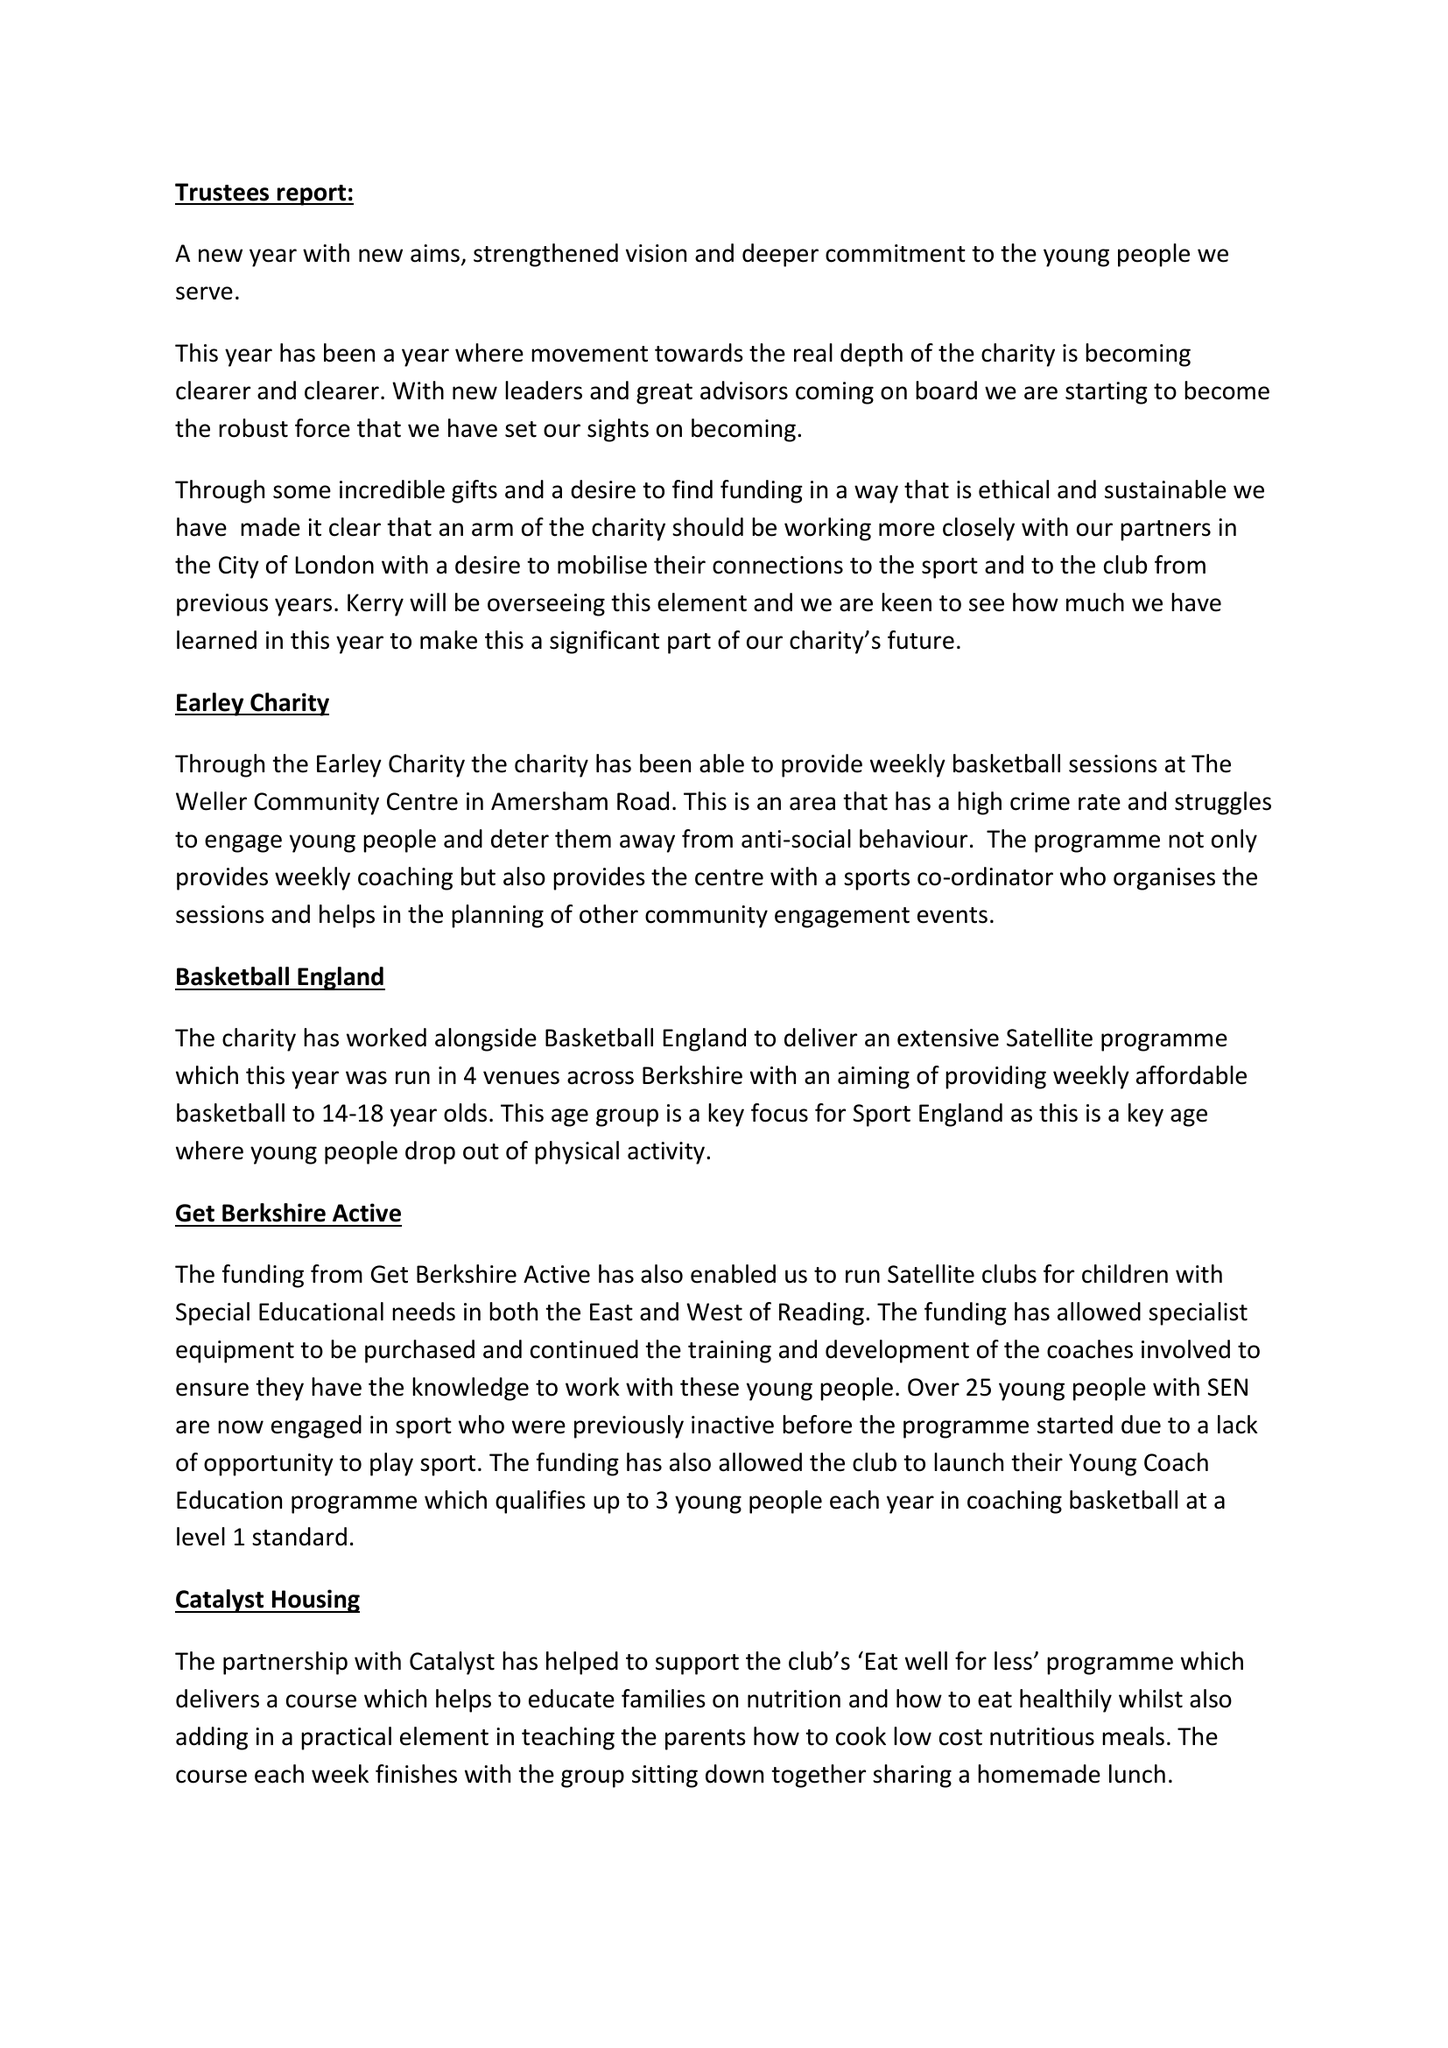What is the value for the address__post_town?
Answer the question using a single word or phrase. READING 